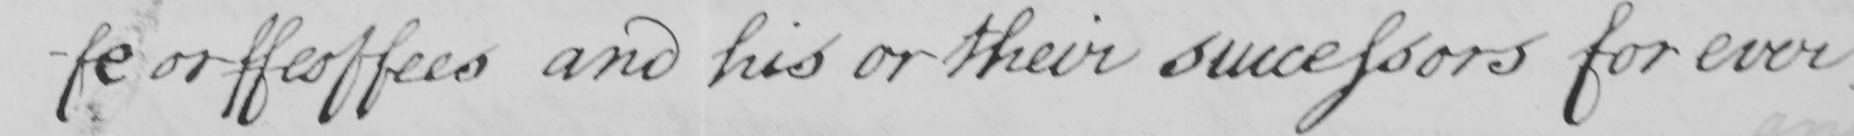Transcribe the text shown in this historical manuscript line. -fe or feoffees and his or their successors for ever 